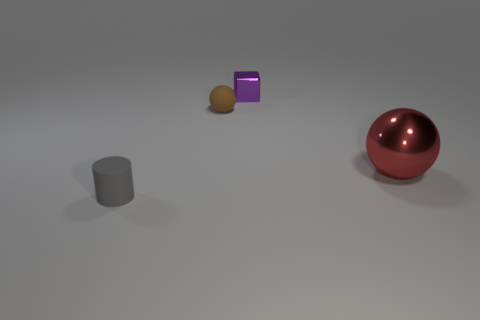Add 1 small brown matte cubes. How many objects exist? 5 Subtract all cylinders. How many objects are left? 3 Add 2 small purple objects. How many small purple objects are left? 3 Add 2 small gray matte cylinders. How many small gray matte cylinders exist? 3 Subtract 0 yellow cubes. How many objects are left? 4 Subtract all large green rubber blocks. Subtract all large red spheres. How many objects are left? 3 